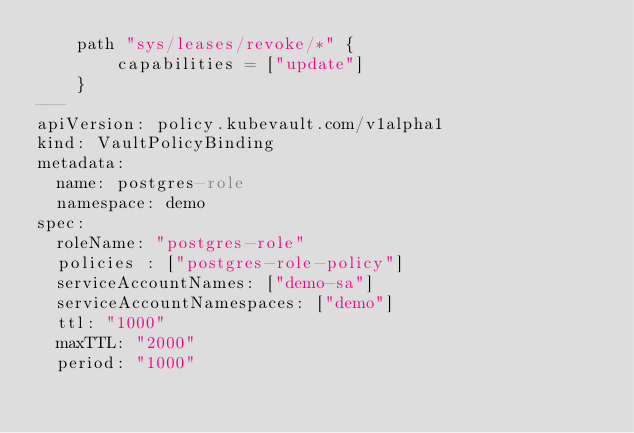<code> <loc_0><loc_0><loc_500><loc_500><_YAML_>    path "sys/leases/revoke/*" {
        capabilities = ["update"]
    }
---
apiVersion: policy.kubevault.com/v1alpha1
kind: VaultPolicyBinding
metadata:
  name: postgres-role
  namespace: demo
spec:
  roleName: "postgres-role"
  policies : ["postgres-role-policy"]
  serviceAccountNames: ["demo-sa"]
  serviceAccountNamespaces: ["demo"]
  ttl: "1000"
  maxTTL: "2000"
  period: "1000"
</code> 